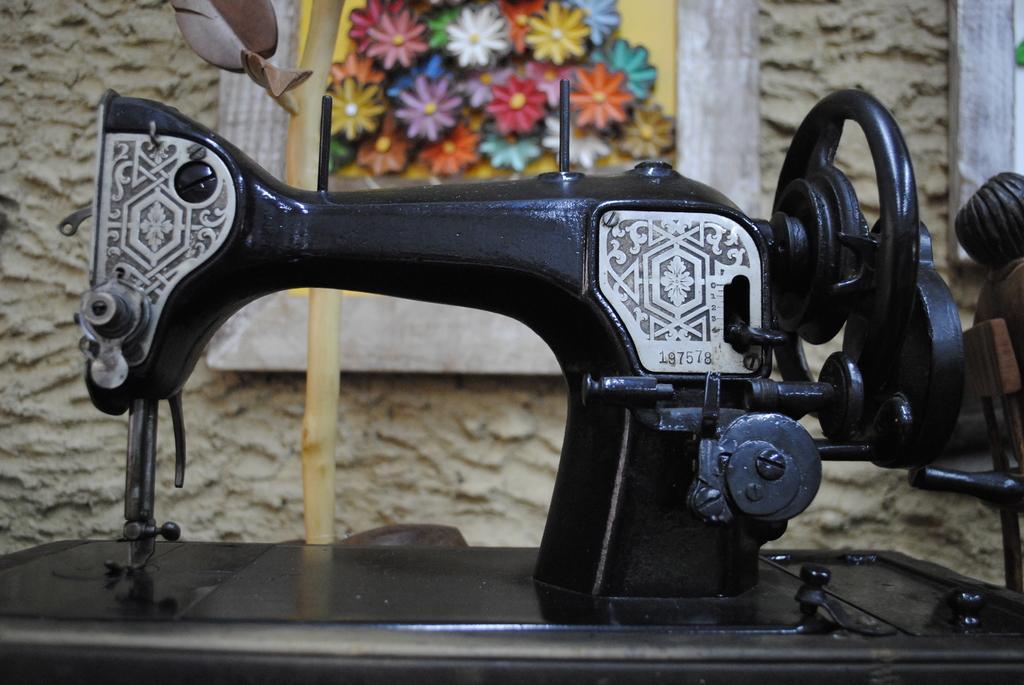How would you summarize this image in a sentence or two? In this image there is a sewing machine, in the background there is a wall for that wall there is a frame. 